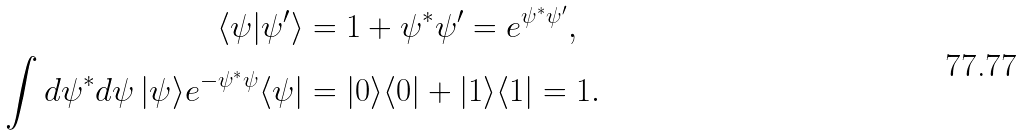Convert formula to latex. <formula><loc_0><loc_0><loc_500><loc_500>\langle \psi | \psi ^ { \prime } \rangle & = 1 + \psi ^ { * } \psi ^ { \prime } = e ^ { \psi ^ { * } \psi ^ { \prime } } , \\ \int d \psi ^ { * } d \psi \, | \psi \rangle e ^ { - \psi ^ { * } \psi } \langle \psi | & = | 0 \rangle \langle 0 | + | 1 \rangle \langle 1 | = 1 .</formula> 